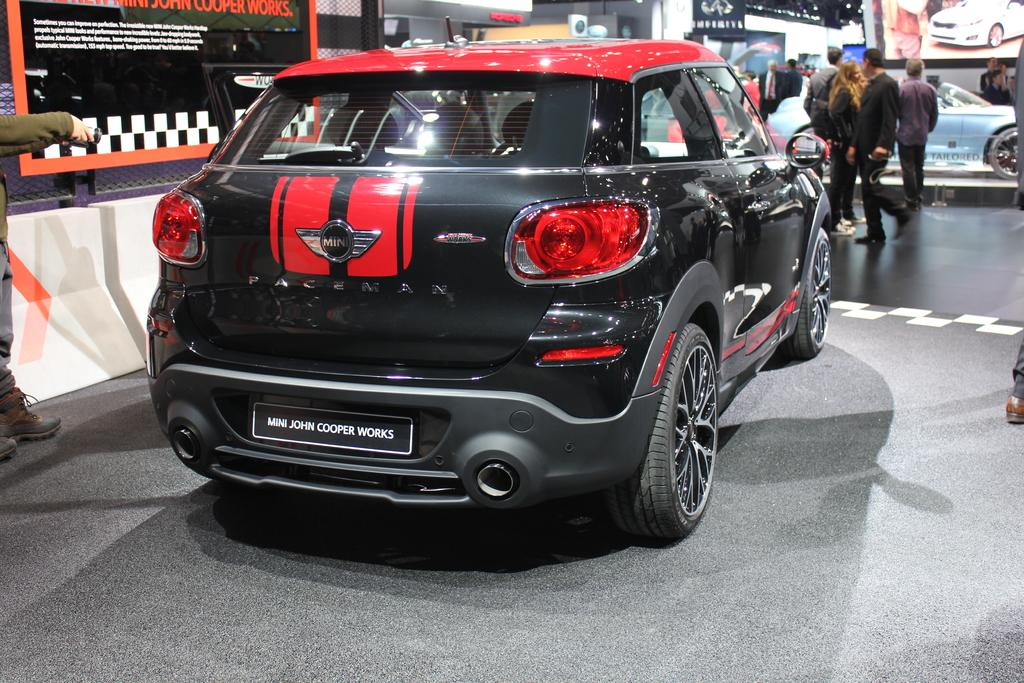What type of vehicles can be seen in the image? There are cars in the image. What else is present in the image besides the cars? There are display boards with text in the image. What are the people in the image doing? People are walking around in the image. What type of string can be seen connecting the cars in the image? There is no string connecting the cars in the image; they are separate vehicles. 